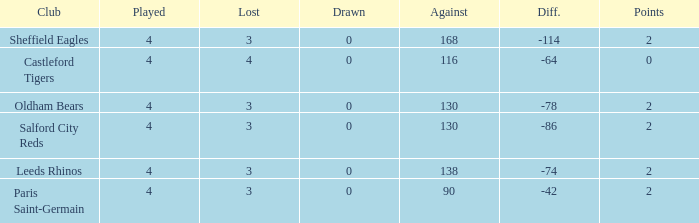What is the sum of losses for teams with less than 4 games played? None. 